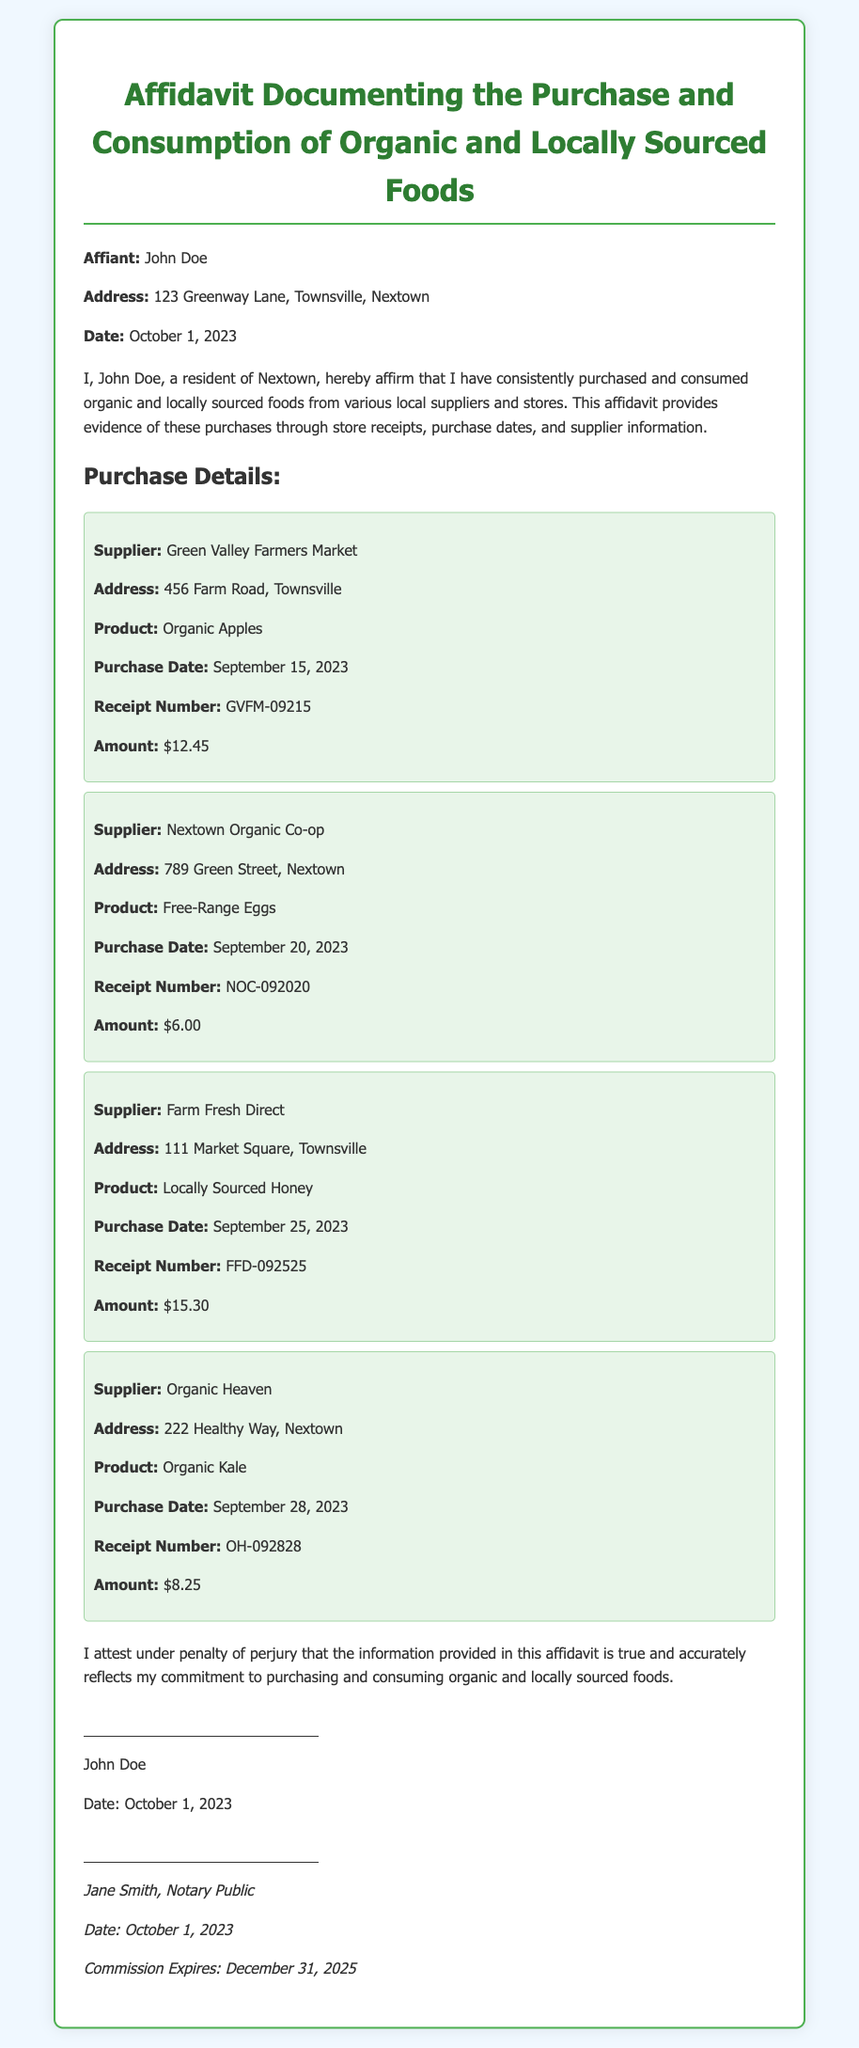What is the name of the affiant? The affiant is the person affirming the document, which is John Doe.
Answer: John Doe What is the purchase date for Organic Apples? The purchase date is provided under the purchase details section for Organic Apples, which is September 15, 2023.
Answer: September 15, 2023 How much did John Doe spend on Free-Range Eggs? The amount spent on Free-Range Eggs is detailed in the purchases section, which is $6.00.
Answer: $6.00 What is the address of the supplier for Locally Sourced Honey? The address for the supplier is listed in the purchase details for Locally Sourced Honey, which is 111 Market Square, Townsville.
Answer: 111 Market Square, Townsville Which product was purchased from Organic Heaven? The product purchased from Organic Heaven is specified in the purchases section, which is Organic Kale.
Answer: Organic Kale How many different suppliers are mentioned in the affidavit? The affidavit lists multiple suppliers, specifically four unique suppliers for the purchases made.
Answer: Four What is the expiration date of the notary's commission? The notary's commission expiration date is provided at the end of the document and is December 31, 2025.
Answer: December 31, 2025 Who is the notary public for this affidavit? The notary public's name is mentioned in the signatures section of the document, which is Jane Smith.
Answer: Jane Smith Is the affidavit dated? The affidavit includes a date specified at the beginning and end, indicating when it was signed, which is October 1, 2023.
Answer: October 1, 2023 